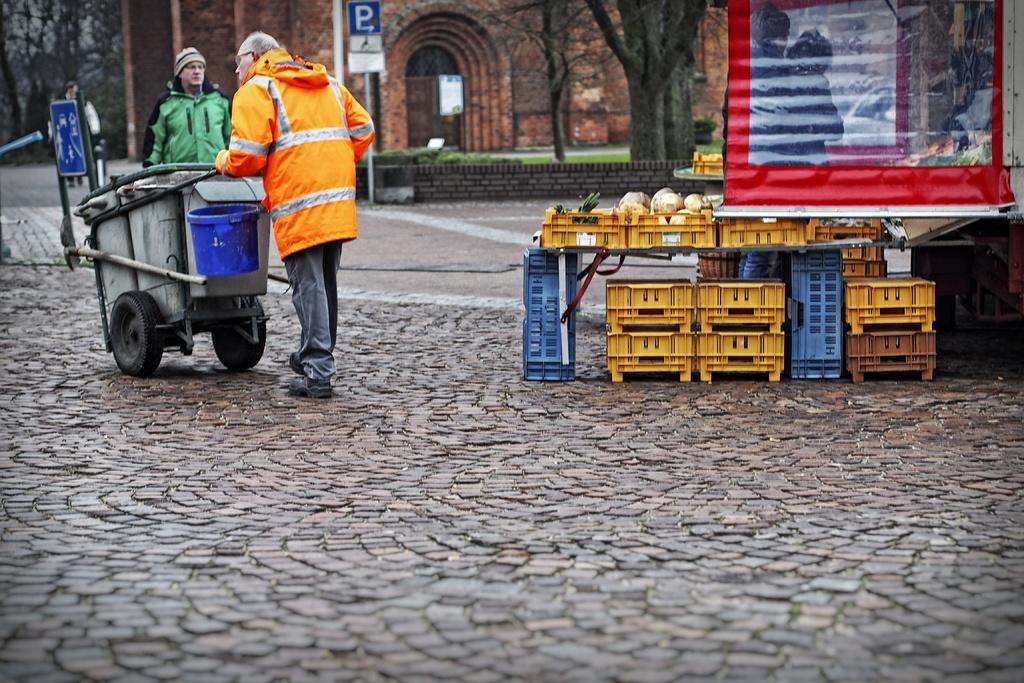What is hanging or displayed in the image? There is a banner in the image. What can be found in the basket in the image? There is a basket with vegetables in the image. What type of vehicle is present in the image? There is a trolley in the image. What container is visible in the image? There is a bucket in the image. What type of informational signs are present in the image? There are signboards in the image. How many people are on the ground in the image? There are two people on the ground in the image. What type of natural elements can be seen in the image? There are trees in the image. What type of structure is visible in the background of the image? There is a building in the background of the image. What type of sweater is the wren wearing in the image? There is no wren or sweater present in the image. How much money is being exchanged between the two people on the ground in the image? There is no indication of any money exchange in the image; the two people are simply standing on the ground. 